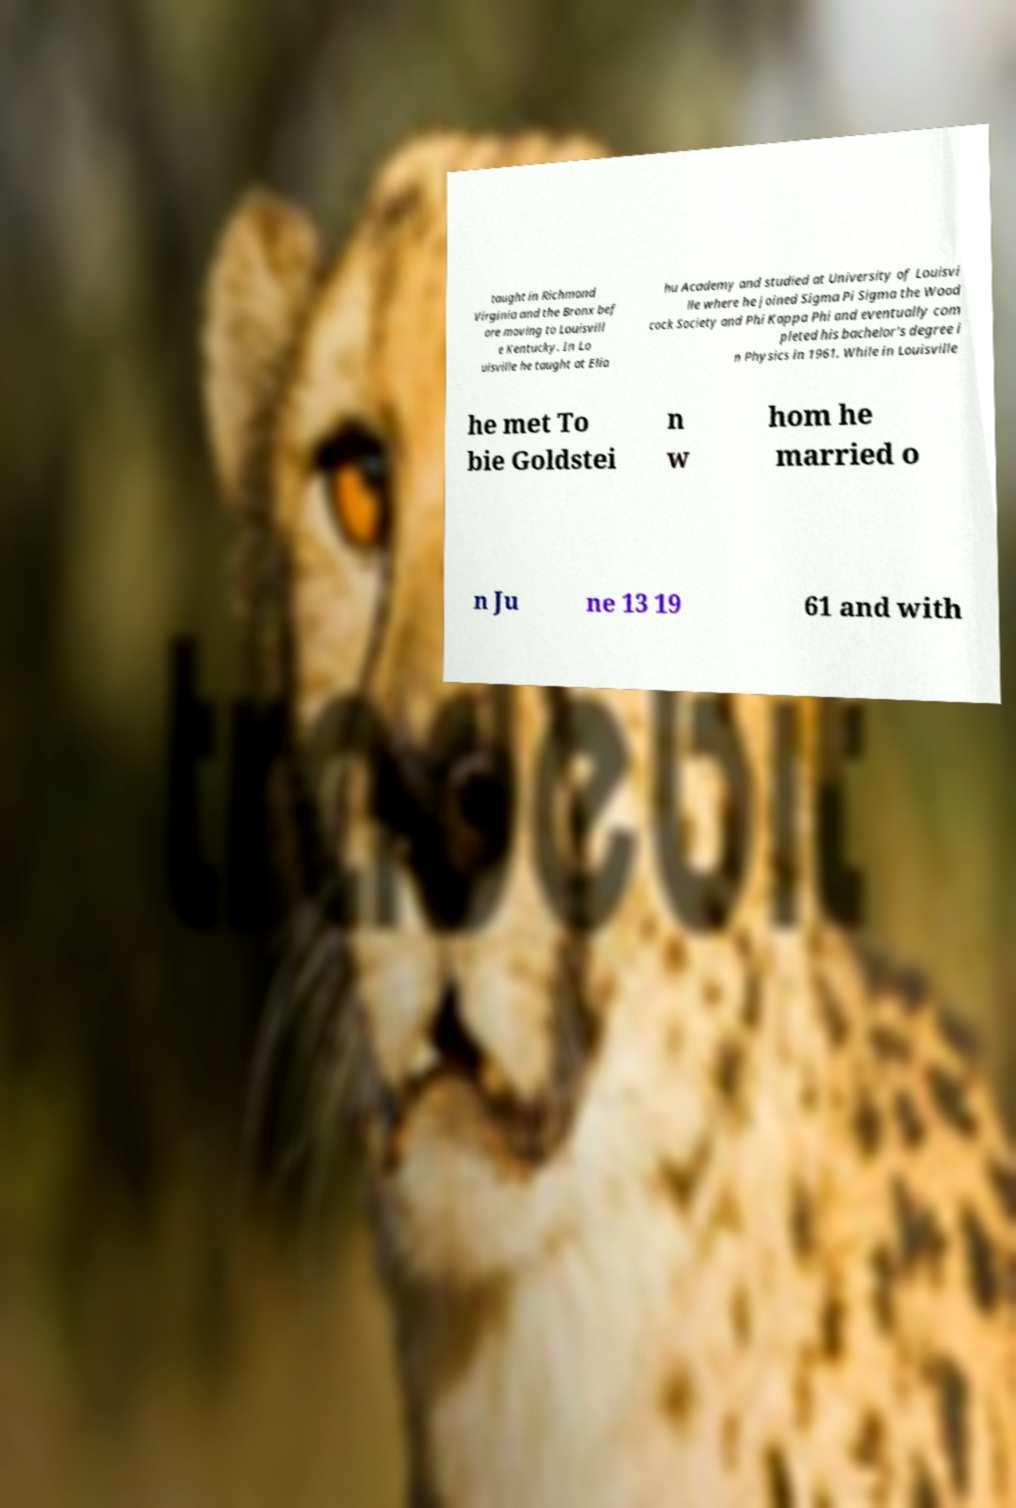Could you extract and type out the text from this image? taught in Richmond Virginia and the Bronx bef ore moving to Louisvill e Kentucky. In Lo uisville he taught at Elia hu Academy and studied at University of Louisvi lle where he joined Sigma Pi Sigma the Wood cock Society and Phi Kappa Phi and eventually com pleted his bachelor's degree i n Physics in 1961. While in Louisville he met To bie Goldstei n w hom he married o n Ju ne 13 19 61 and with 